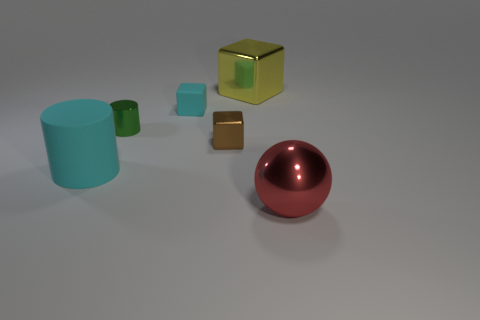Add 4 tiny rubber objects. How many objects exist? 10 Subtract all cylinders. How many objects are left? 4 Subtract 0 blue blocks. How many objects are left? 6 Subtract all brown cubes. Subtract all large cyan rubber cylinders. How many objects are left? 4 Add 6 tiny green cylinders. How many tiny green cylinders are left? 7 Add 1 cyan cylinders. How many cyan cylinders exist? 2 